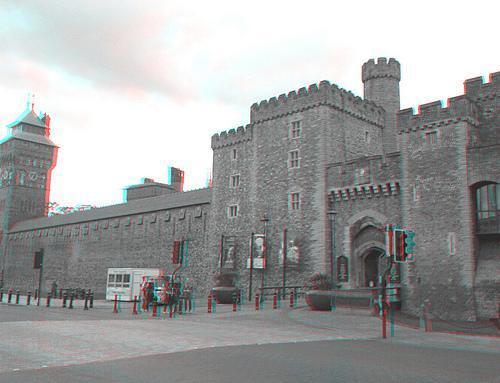How many traffic lights are pictured?
Give a very brief answer. 3. 